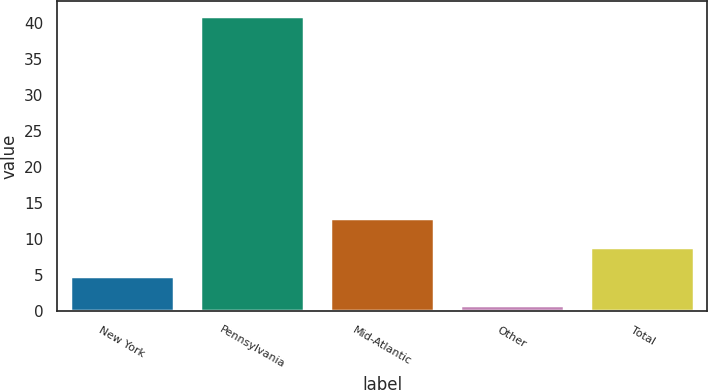Convert chart to OTSL. <chart><loc_0><loc_0><loc_500><loc_500><bar_chart><fcel>New York<fcel>Pennsylvania<fcel>Mid-Atlantic<fcel>Other<fcel>Total<nl><fcel>4.96<fcel>40.98<fcel>12.96<fcel>0.96<fcel>8.96<nl></chart> 